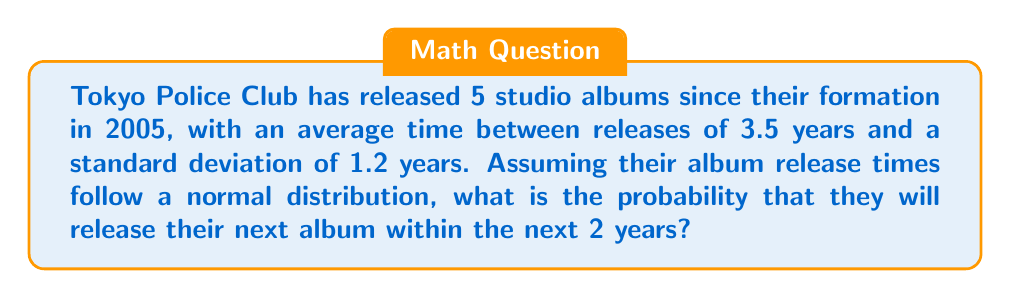Show me your answer to this math problem. To solve this problem, we'll use the properties of the normal distribution and the concept of z-scores.

Step 1: Identify the given information
- Mean time between releases (μ) = 3.5 years
- Standard deviation (σ) = 1.2 years
- Time frame we're interested in (x) = 2 years

Step 2: Calculate the z-score
The z-score represents how many standard deviations away from the mean our value is.
$$ z = \frac{x - \mu}{\sigma} = \frac{2 - 3.5}{1.2} = -1.25 $$

Step 3: Use the standard normal distribution table
We need to find the probability that the next album will be released in less than 2 years, which is equivalent to finding P(Z < -1.25) in the standard normal distribution.

Using a standard normal distribution table or calculator, we find:
$$ P(Z < -1.25) \approx 0.1056 $$

Step 4: Interpret the result
This means there's approximately a 10.56% chance that Tokyo Police Club will release their next album within the next 2 years.
Answer: 0.1056 or 10.56% 